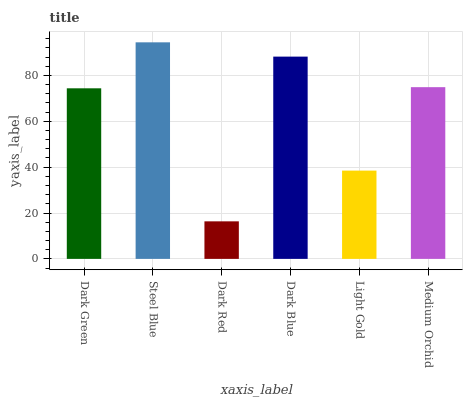Is Steel Blue the minimum?
Answer yes or no. No. Is Dark Red the maximum?
Answer yes or no. No. Is Steel Blue greater than Dark Red?
Answer yes or no. Yes. Is Dark Red less than Steel Blue?
Answer yes or no. Yes. Is Dark Red greater than Steel Blue?
Answer yes or no. No. Is Steel Blue less than Dark Red?
Answer yes or no. No. Is Medium Orchid the high median?
Answer yes or no. Yes. Is Dark Green the low median?
Answer yes or no. Yes. Is Light Gold the high median?
Answer yes or no. No. Is Medium Orchid the low median?
Answer yes or no. No. 